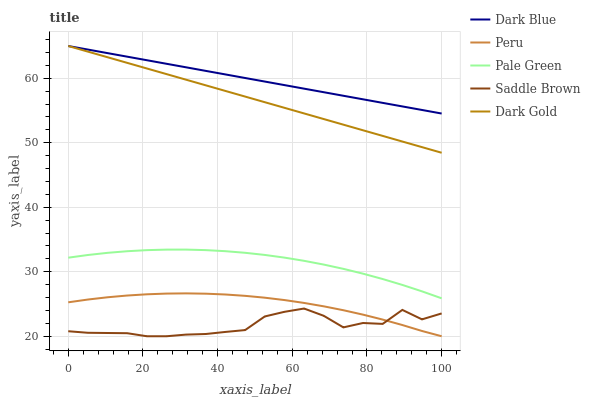Does Saddle Brown have the minimum area under the curve?
Answer yes or no. Yes. Does Dark Blue have the maximum area under the curve?
Answer yes or no. Yes. Does Pale Green have the minimum area under the curve?
Answer yes or no. No. Does Pale Green have the maximum area under the curve?
Answer yes or no. No. Is Dark Blue the smoothest?
Answer yes or no. Yes. Is Saddle Brown the roughest?
Answer yes or no. Yes. Is Pale Green the smoothest?
Answer yes or no. No. Is Pale Green the roughest?
Answer yes or no. No. Does Saddle Brown have the lowest value?
Answer yes or no. Yes. Does Pale Green have the lowest value?
Answer yes or no. No. Does Dark Gold have the highest value?
Answer yes or no. Yes. Does Pale Green have the highest value?
Answer yes or no. No. Is Saddle Brown less than Dark Gold?
Answer yes or no. Yes. Is Pale Green greater than Saddle Brown?
Answer yes or no. Yes. Does Dark Gold intersect Dark Blue?
Answer yes or no. Yes. Is Dark Gold less than Dark Blue?
Answer yes or no. No. Is Dark Gold greater than Dark Blue?
Answer yes or no. No. Does Saddle Brown intersect Dark Gold?
Answer yes or no. No. 